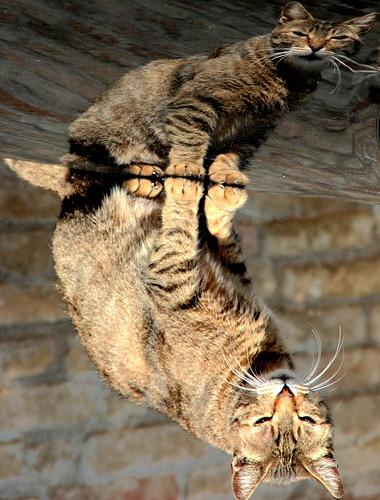Is the cat scared of water?
Be succinct. Yes. Is this cat indoors or outdoors?
Answer briefly. Outdoors. How many animals are in the photo?
Be succinct. 1. 